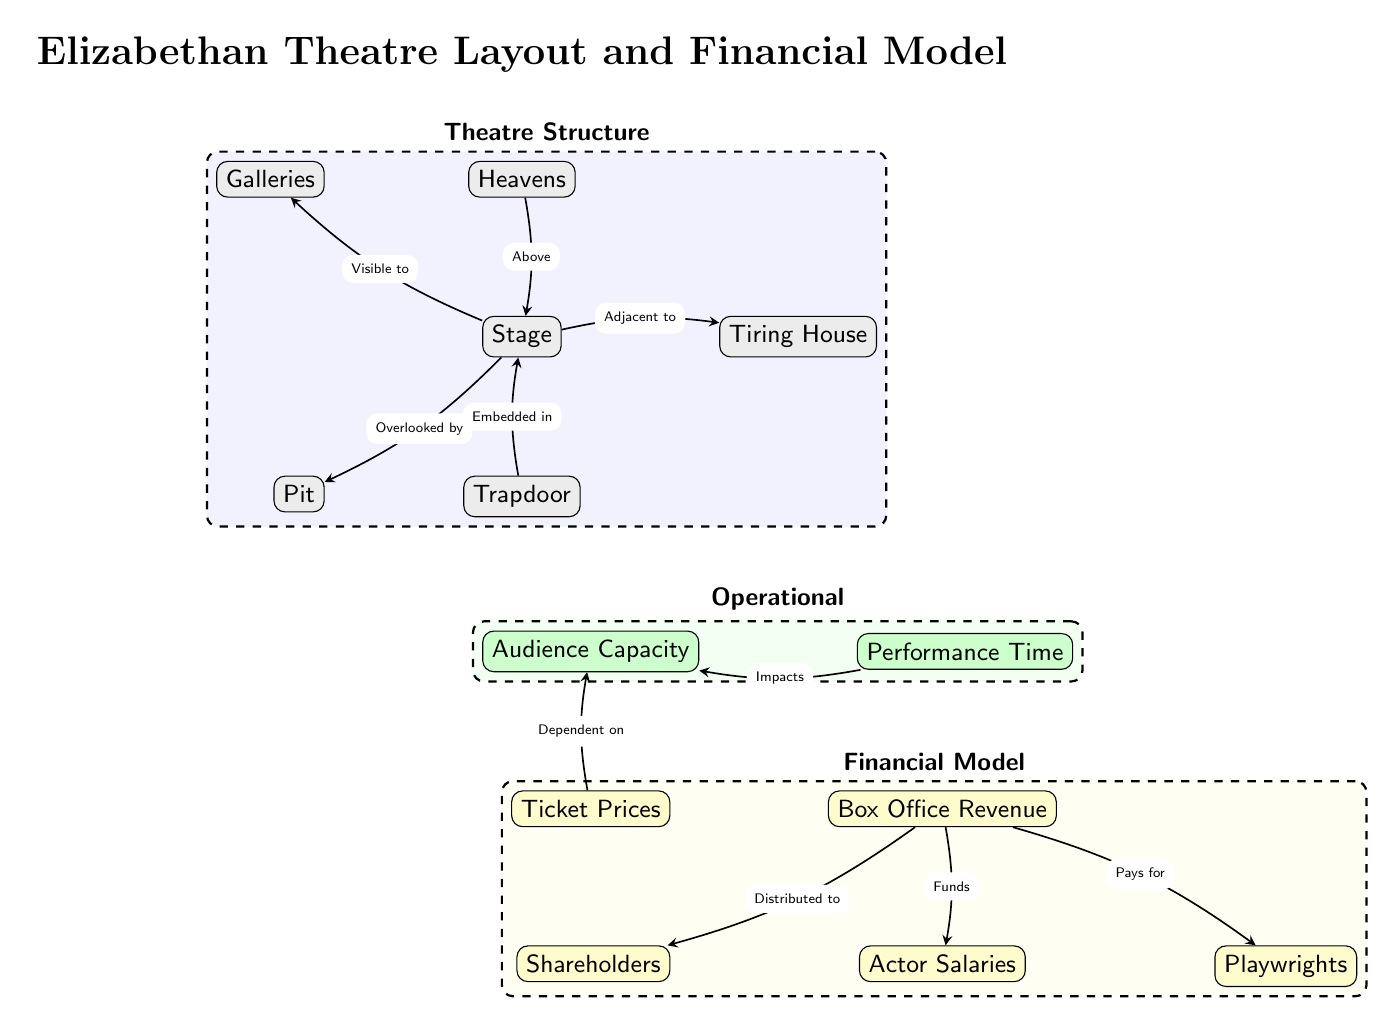What is the primary physical element of the diagram? The primary physical element is represented at the top of the diagram and is labeled as "Stage."
Answer: Stage What lies directly below the stage in the diagram? The diagram indicates that the "Pit" is directly below the "Stage."
Answer: Pit What is the relationship between ticket prices and audience capacity? The edge from "Ticket Prices" to "Audience Capacity" indicates that ticket prices are dependent on or contingent upon audience capacity, suggesting a direct link between the two.
Answer: Dependent on How many financial elements are present in the diagram? By counting the nodes labeled as financial, which include "Ticket Prices," "Box Office Revenue," "Shareholders," "Actor Salaries," and "Playwrights," we find there are five financial elements in total.
Answer: 5 What does "Box Office Revenue" distribute to according to the diagram? From the diagram, "Box Office Revenue" distributes to "Shareholders," which indicates where a portion of the profits goes.
Answer: Shareholders How does performance time impact audience capacity? The arrow from "Performance Time" to "Audience Capacity" suggests that performance time has an impact on the audience capacity, hinting that longer or shorter performances could affect the number of spectators.
Answer: Impacts What is the physical structure located directly above the stage? The node labeled "Heavens," which is placed above the "Stage" in the diagram, indicates that it is a significant aspect of the physical structure in Elizabethan theatre.
Answer: Heavens How are actor salaries funded according to the financial model in the diagram? The diagram shows that "Box Office Revenue" funds "Actor Salaries," indicating a direct financial flow from ticket sales to compensation for the performers.
Answer: Funds Which physical element has a trapdoor embedded in it? The diagram specifies that the "Trapdoor" is embedded within the "Stage," highlighting its structural significance in theatrical performances.
Answer: Stage 